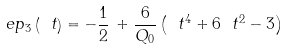Convert formula to latex. <formula><loc_0><loc_0><loc_500><loc_500>\ e p _ { 3 } \left ( \ t \right ) = - \frac { 1 } { 2 } \, + \frac { 6 } { Q _ { 0 } } \left ( \ t ^ { 4 } + 6 \ t ^ { 2 } - 3 \right )</formula> 